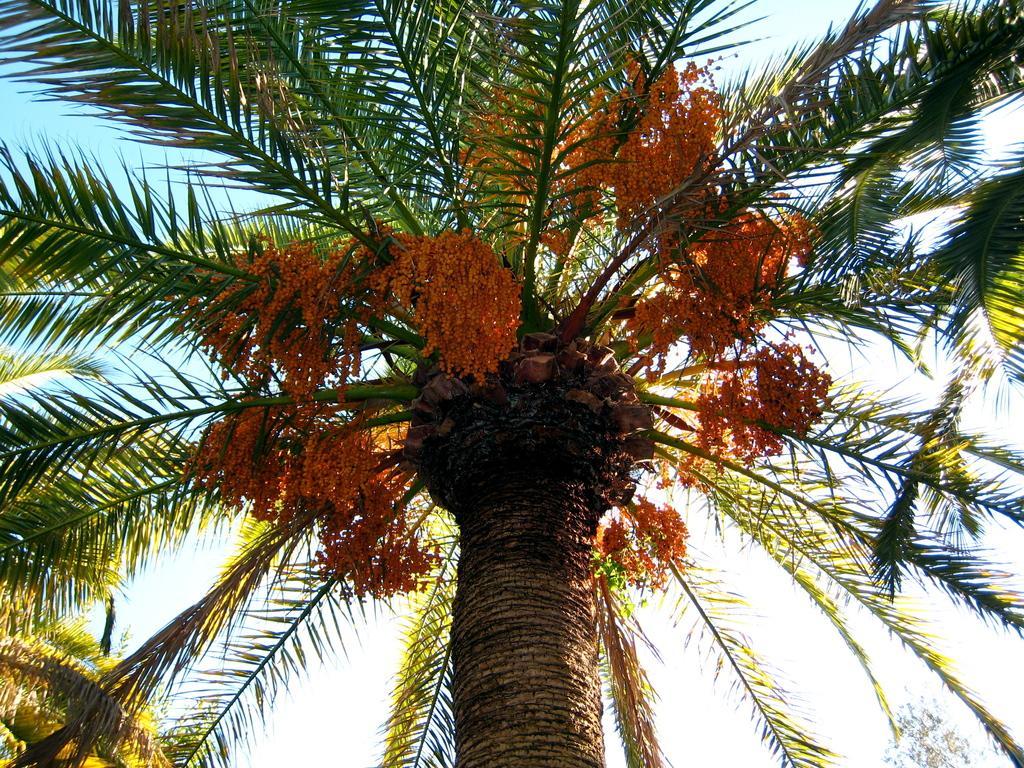Could you give a brief overview of what you see in this image? In this image we can see a picture of a palm tree which has long leaves and some yellow color flowers. 